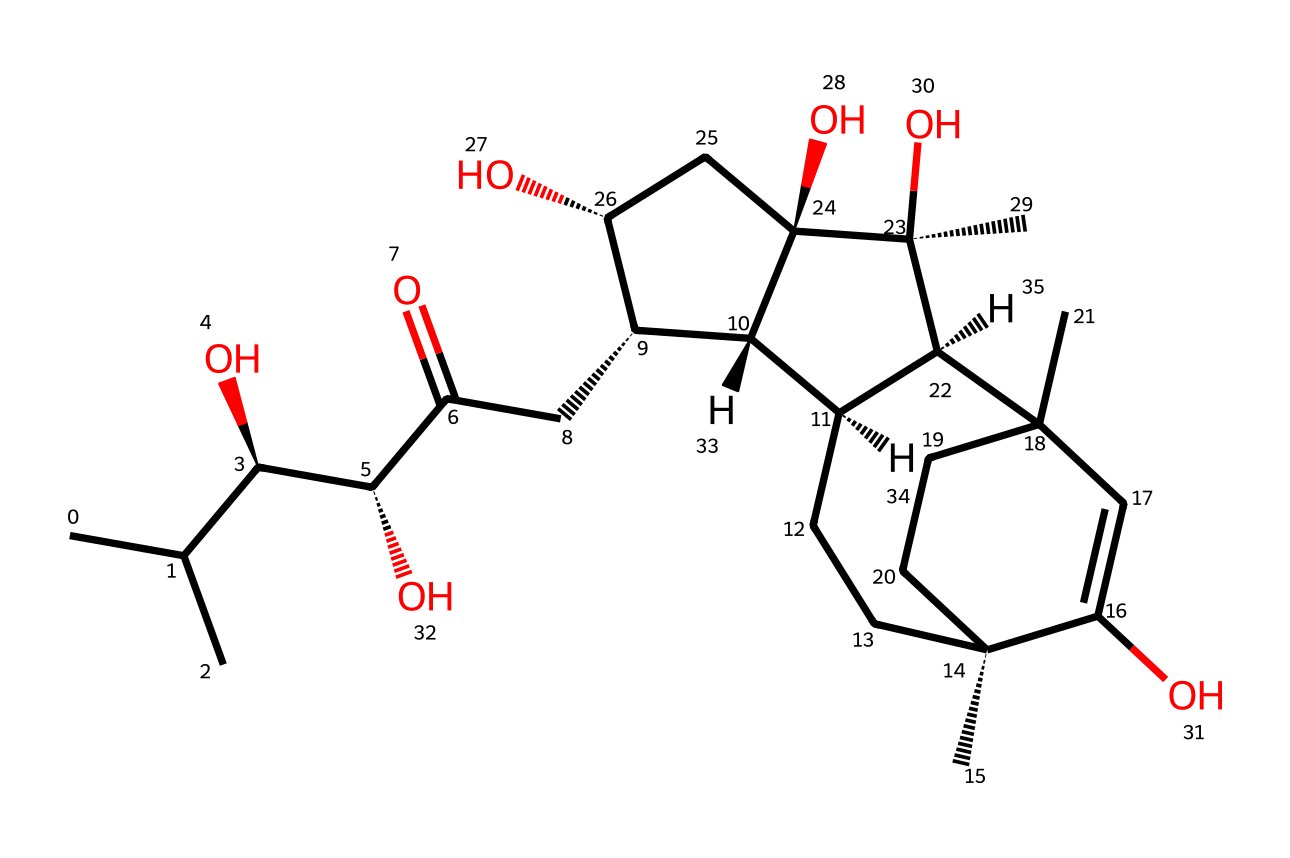What is the molecular formula of this compound? To derive the molecular formula, count the number of each type of atom in the chemical structure represented by the SMILES. Through analyzing the structure, you can identify carbon (C), hydrogen (H), and oxygen (O) atoms. Specifically, this structure has 27 carbons, 44 hydrogens, and 6 oxygens, leading to the molecular formula C27H44O6.
Answer: C27H44O6 How many chiral centers are present in this molecule? The chiral centers are identified by looking for carbon atoms that are bonded to four different substituents. Upon examining the structure derived from the SMILES, you can pinpoint that there are 5 chiral centers based on the arrangement of groups around specific carbon atoms.
Answer: 5 What is the primary role of ecdysteroids in insects? Ecdysteroids primarily function as hormones regulating molting and development in insects. They signal the organism to undergo development processes such as metamorphosis and growth stages, acting on various tissues to facilitate these changes.
Answer: hormones Does this compound contain any cyclic structures? By analyzing the molecule's structure, you can observe multiple ring formations (cyclic structures), which are characteristic of the sterol family to which ecdysteroids belong. The representation highlights several interconnected rings within the compound.
Answer: yes What type of chemical is this, specifically in the context of insect physiology? This compound is classified as an ecdysteroid, which is a steroid hormone specifically important for regulating growth and development processes during an insect's life cycle. It plays a crucial role in hormonal signaling during molting and developmental transitions.
Answer: ecdysteroid What functional groups are present in this structure? By visual inspection of the provided SMILES, you can identify various functional groups, including hydroxyl (-OH) groups, which are confirmed by the presence of several hydroxyl-bearing carbons in the structure. This adds to the compound's solubility and biological activity.
Answer: hydroxyl groups 